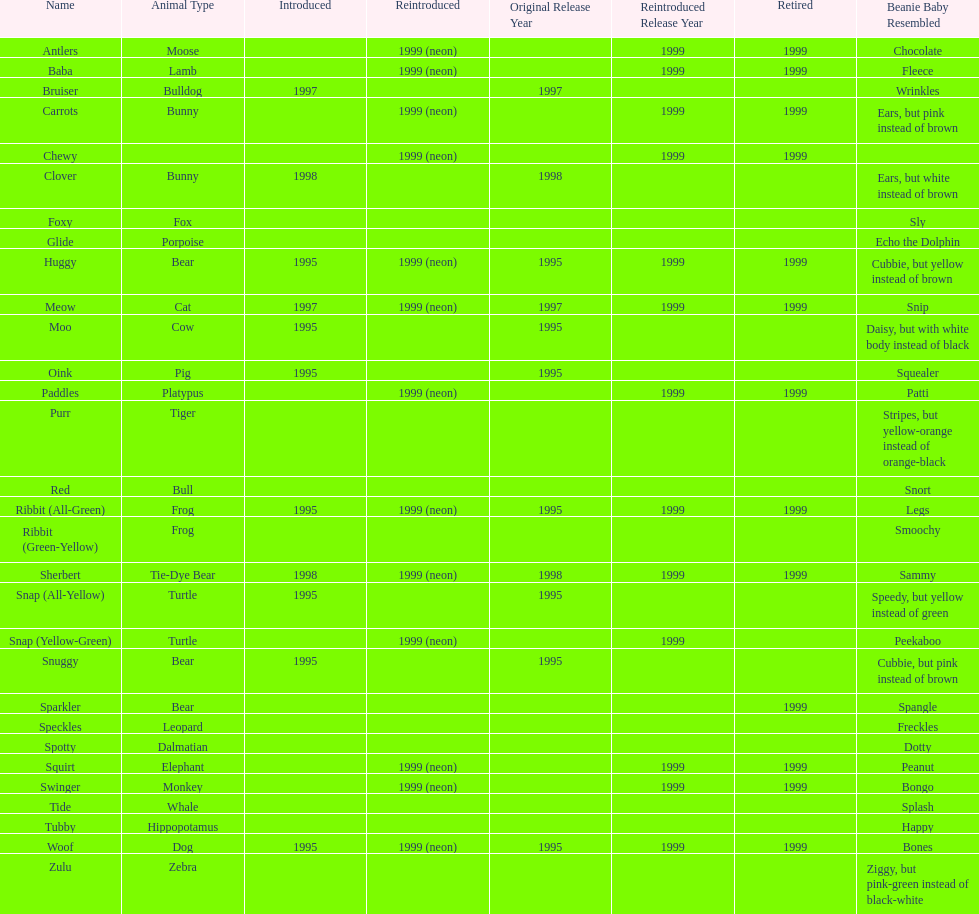Which animal type has the most pillow pals? Bear. 